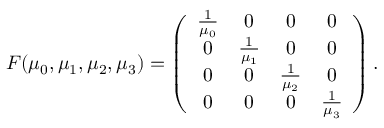<formula> <loc_0><loc_0><loc_500><loc_500>\begin{array} { r } { F ( \mu _ { 0 } , \mu _ { 1 } , \mu _ { 2 } , \mu _ { 3 } ) = \left ( \begin{array} { c c c c } { \frac { 1 } \mu _ { 0 } } } & { 0 } & { 0 } & { 0 } \\ { 0 } & { \frac { 1 } \mu _ { 1 } } } & { 0 } & { 0 } \\ { 0 } & { 0 } & { \frac { 1 } \mu _ { 2 } } } & { 0 } \\ { 0 } & { 0 } & { 0 } & { \frac { 1 } \mu _ { 3 } } } \end{array} \right ) . } \end{array}</formula> 